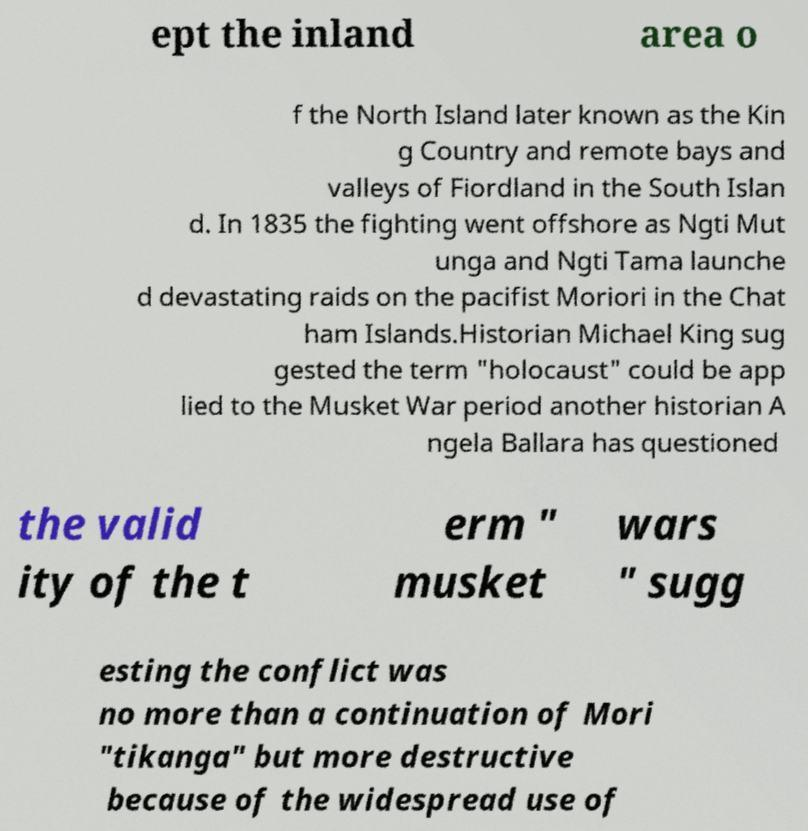For documentation purposes, I need the text within this image transcribed. Could you provide that? ept the inland area o f the North Island later known as the Kin g Country and remote bays and valleys of Fiordland in the South Islan d. In 1835 the fighting went offshore as Ngti Mut unga and Ngti Tama launche d devastating raids on the pacifist Moriori in the Chat ham Islands.Historian Michael King sug gested the term "holocaust" could be app lied to the Musket War period another historian A ngela Ballara has questioned the valid ity of the t erm " musket wars " sugg esting the conflict was no more than a continuation of Mori "tikanga" but more destructive because of the widespread use of 